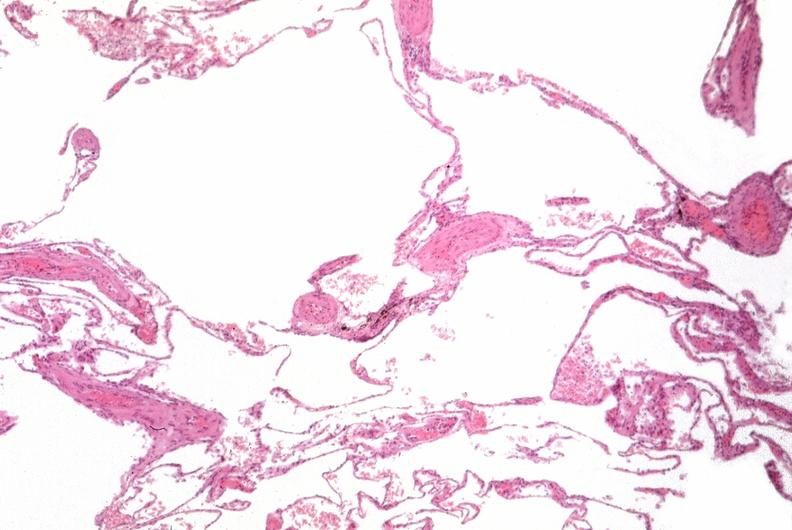s chronic myelogenous leukemia present?
Answer the question using a single word or phrase. No 